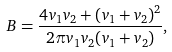<formula> <loc_0><loc_0><loc_500><loc_500>B = \frac { 4 v _ { 1 } v _ { 2 } + ( v _ { 1 } + v _ { 2 } ) ^ { 2 } } { 2 \pi v _ { 1 } v _ { 2 } ( v _ { 1 } + v _ { 2 } ) } ,</formula> 